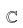<formula> <loc_0><loc_0><loc_500><loc_500>\mathbb { C }</formula> 